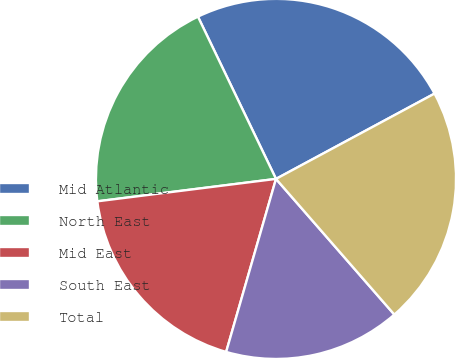Convert chart. <chart><loc_0><loc_0><loc_500><loc_500><pie_chart><fcel>Mid Atlantic<fcel>North East<fcel>Mid East<fcel>South East<fcel>Total<nl><fcel>24.28%<fcel>19.85%<fcel>18.55%<fcel>15.88%<fcel>21.44%<nl></chart> 